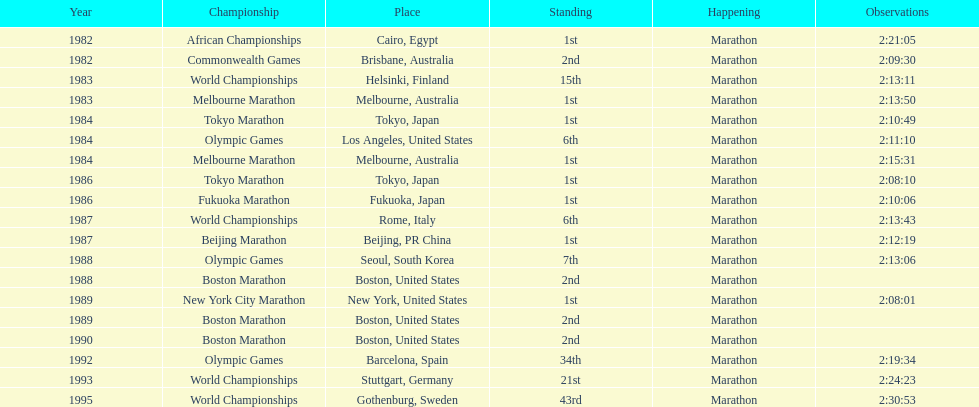In what year did the runner participate in the most marathons? 1984. 